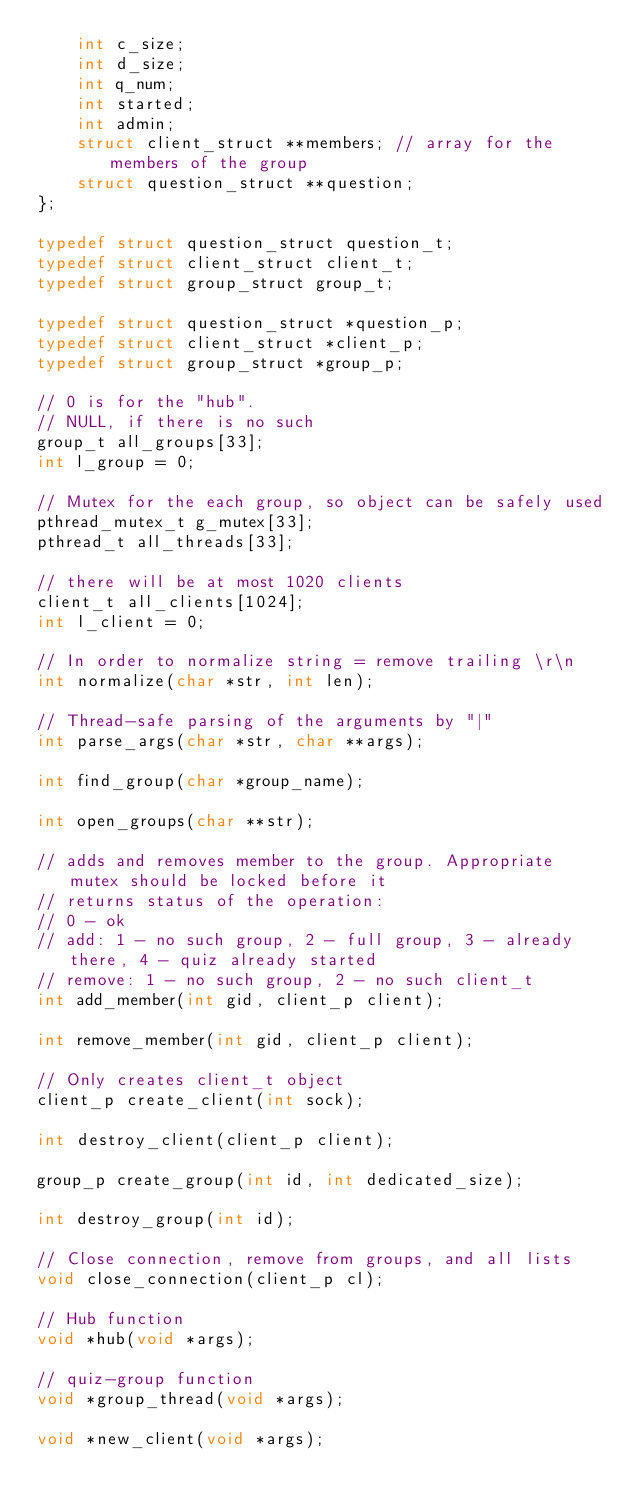Convert code to text. <code><loc_0><loc_0><loc_500><loc_500><_C_>    int c_size;
    int d_size;
    int q_num;
    int started;
    int admin;
    struct client_struct **members; // array for the members of the group
    struct question_struct **question;
};

typedef struct question_struct question_t;
typedef struct client_struct client_t;
typedef struct group_struct group_t;

typedef struct question_struct *question_p;
typedef struct client_struct *client_p;
typedef struct group_struct *group_p;

// 0 is for the "hub".
// NULL, if there is no such
group_t all_groups[33];
int l_group = 0;

// Mutex for the each group, so object can be safely used
pthread_mutex_t g_mutex[33];
pthread_t all_threads[33];

// there will be at most 1020 clients
client_t all_clients[1024];
int l_client = 0;

// In order to normalize string = remove trailing \r\n
int normalize(char *str, int len);

// Thread-safe parsing of the arguments by "|"
int parse_args(char *str, char **args);

int find_group(char *group_name);

int open_groups(char **str);

// adds and removes member to the group. Appropriate mutex should be locked before it
// returns status of the operation:
// 0 - ok
// add: 1 - no such group, 2 - full group, 3 - already there, 4 - quiz already started
// remove: 1 - no such group, 2 - no such client_t
int add_member(int gid, client_p client);

int remove_member(int gid, client_p client);

// Only creates client_t object
client_p create_client(int sock);

int destroy_client(client_p client);

group_p create_group(int id, int dedicated_size);

int destroy_group(int id);

// Close connection, remove from groups, and all lists
void close_connection(client_p cl);

// Hub function
void *hub(void *args);

// quiz-group function
void *group_thread(void *args);

void *new_client(void *args);</code> 